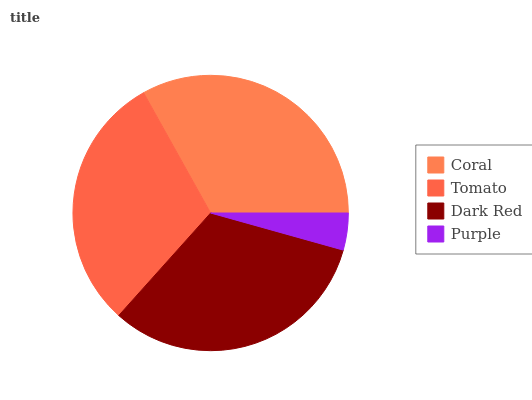Is Purple the minimum?
Answer yes or no. Yes. Is Coral the maximum?
Answer yes or no. Yes. Is Tomato the minimum?
Answer yes or no. No. Is Tomato the maximum?
Answer yes or no. No. Is Coral greater than Tomato?
Answer yes or no. Yes. Is Tomato less than Coral?
Answer yes or no. Yes. Is Tomato greater than Coral?
Answer yes or no. No. Is Coral less than Tomato?
Answer yes or no. No. Is Dark Red the high median?
Answer yes or no. Yes. Is Tomato the low median?
Answer yes or no. Yes. Is Tomato the high median?
Answer yes or no. No. Is Dark Red the low median?
Answer yes or no. No. 